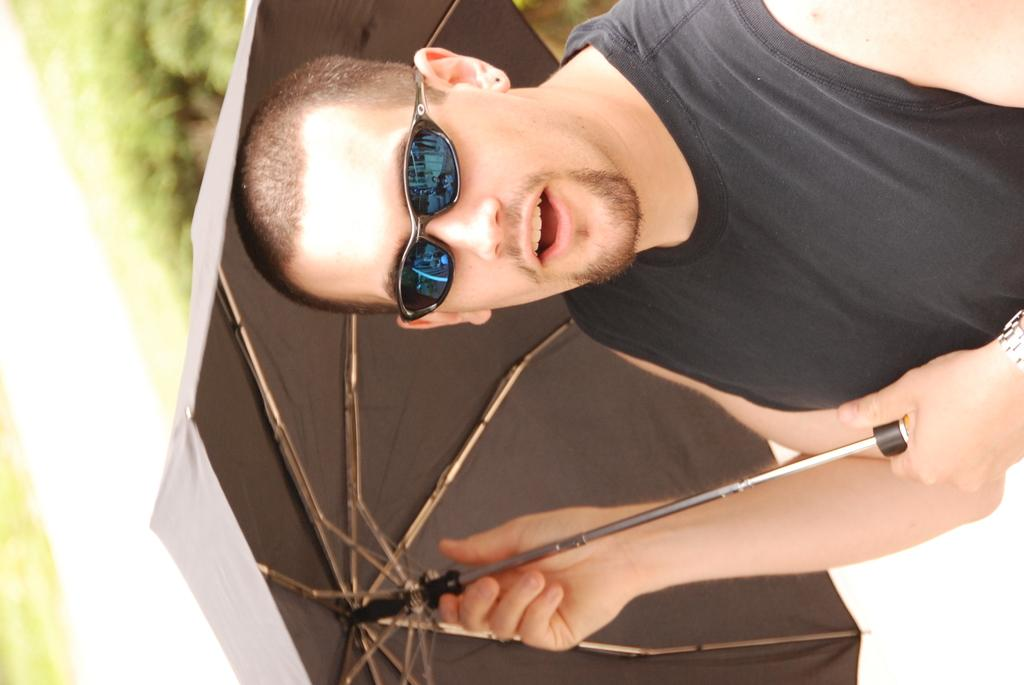Who is the main subject in the image? There is a man in the image. What is the man wearing? The man is wearing a black T-shirt. What object is the man holding in the image? The man is holding an umbrella. Can you describe the background of the image? The background of the image is blurry. What type of brush is the man using to clean the mine in the image? There is no brush or mine present in the image. The man is holding an umbrella, and the background is blurry. 